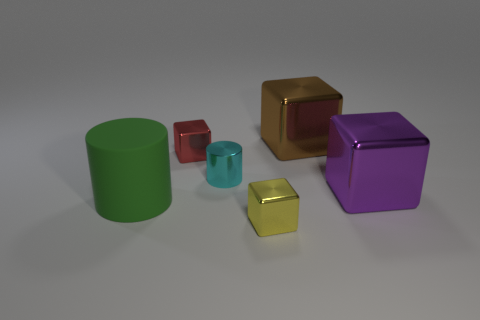Is there any other thing that is the same material as the large green object?
Your response must be concise. No. Are there fewer big green matte objects behind the purple object than small cyan matte things?
Your response must be concise. No. What size is the metallic object that is on the left side of the tiny cylinder?
Provide a short and direct response. Small. What is the color of the other shiny object that is the same shape as the large green thing?
Make the answer very short. Cyan. How many metal blocks have the same color as the large matte object?
Offer a very short reply. 0. Are there any other things that have the same shape as the large rubber thing?
Ensure brevity in your answer.  Yes. There is a metallic cube on the left side of the small metallic block that is on the right side of the small red cube; are there any blocks in front of it?
Give a very brief answer. Yes. What number of other large cubes are made of the same material as the yellow block?
Your answer should be compact. 2. There is a object in front of the green matte object; is its size the same as the shiny cube that is behind the red shiny object?
Make the answer very short. No. What color is the tiny block behind the big thing that is left of the tiny cube to the left of the yellow thing?
Offer a terse response. Red. 